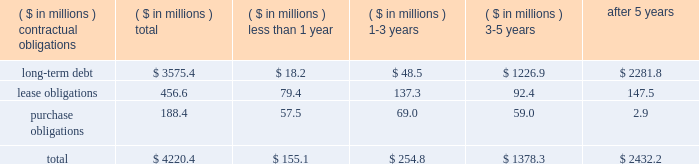The company consolidates the assets and liabilities of several entities from which it leases office buildings and corporate aircraft .
These entities have been determined to be variable interest entities and the company has been determined to be the primary beneficiary of these entities .
Due to the consolidation of these entities , the company reflects in its balance sheet : property , plant and equipment of $ 156 million and $ 183 million , other assets of $ 14 million and $ 12 million , long-term debt of $ 150 million ( including current maturities of $ 6 million ) and $ 192 million ( including current maturities of $ 8 million ) , minority interest liabilities of $ 22 million and $ 6 million , and other accrued liabilities of $ 1 million and $ 0 , as of may 27 , 2007 and may 28 , 2006 , respectively .
The liabilities recognized as a result of consolidating these entities do not represent additional claims on the general assets of the company .
The creditors of these entities have claims only on the assets of the specific variable interest entities .
Obligations and commitments as part of its ongoing operations , the company enters into arrangements that obligate the company to make future payments under contracts such as debt agreements , lease agreements , and unconditional purchase obligations ( i.e. , obligations to transfer funds in the future for fixed or minimum quantities of goods or services at fixed or minimum prices , such as 201ctake-or-pay 201d contracts ) .
The unconditional purchase obligation arrangements are entered into by the company in its normal course of business in order to ensure adequate levels of sourced product are available to the company .
Capital lease and debt obligations , which totaled $ 3.6 billion at may 27 , 2007 , are currently recognized as liabilities in the company 2019s consolidated balance sheet .
Operating lease obligations and unconditional purchase obligations , which totaled $ 645 million at may 27 , 2007 , are not recognized as liabilities in the company 2019s consolidated balance sheet , in accordance with generally accepted accounting principles .
A summary of the company 2019s contractual obligations at the end of fiscal 2007 is as follows ( including obligations of discontinued operations ) : .
The company 2019s total obligations of approximately $ 4.2 billion reflect a decrease of approximately $ 237 million from the company 2019s 2006 fiscal year-end .
The decrease was due primarily to a reduction of lease obligations in connection with the sale of the packaged meats operations .
The company is also contractually obligated to pay interest on its long-term debt obligations .
The weighted average interest rate of the long-term debt obligations outstanding as of may 27 , 2007 was approximately 7.2%. .
What percentage of the total contractual obligations at the end of fiscal 2007 are comprised of lease obligations? 
Computations: (456.6 / 4220.4)
Answer: 0.10819. 